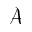<formula> <loc_0><loc_0><loc_500><loc_500>\ m a t h s c r { A }</formula> 